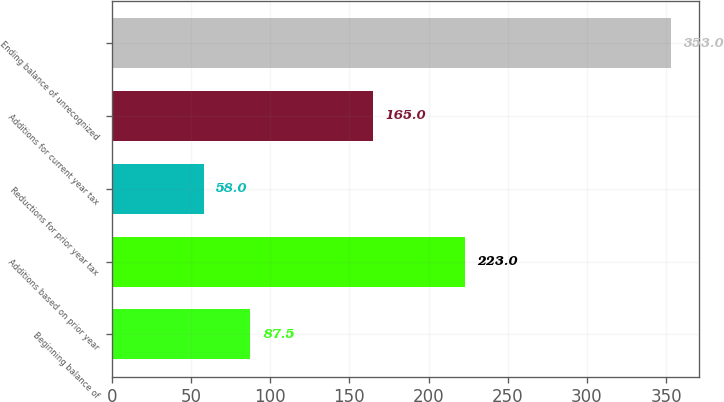<chart> <loc_0><loc_0><loc_500><loc_500><bar_chart><fcel>Beginning balance of<fcel>Additions based on prior year<fcel>Reductions for prior year tax<fcel>Additions for current year tax<fcel>Ending balance of unrecognized<nl><fcel>87.5<fcel>223<fcel>58<fcel>165<fcel>353<nl></chart> 